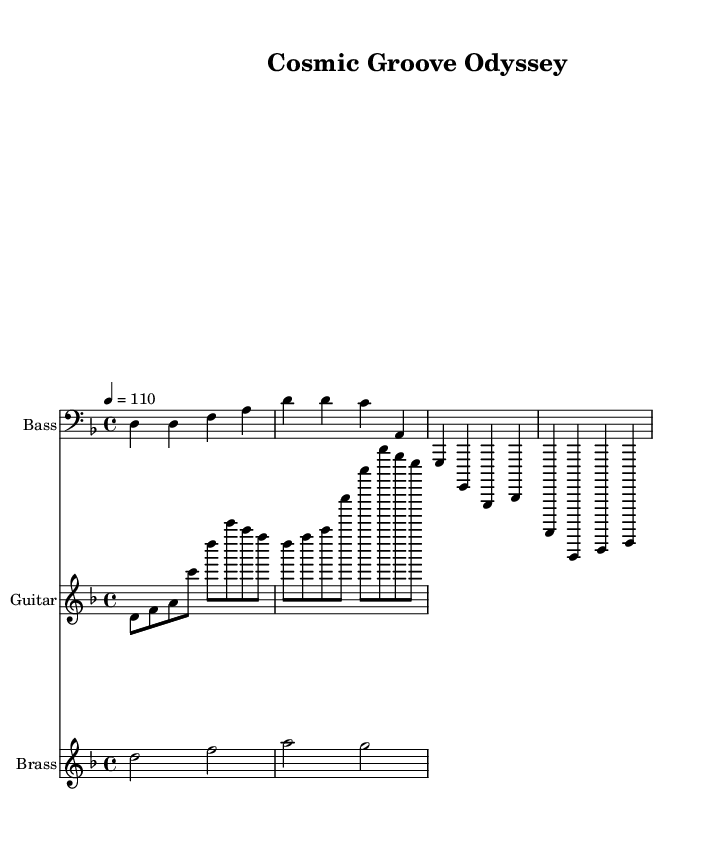What is the key signature of this music? The key signature of the music is indicated at the beginning of the score. It includes one flat (B♭), which signifies the key of D minor.
Answer: D minor What is the time signature of the piece? The time signature is displayed at the beginning of the score and is represented as 4/4, indicating four beats per measure and the quarter note gets one beat.
Answer: 4/4 What is the tempo marking for the music? The tempo marking is specified at the beginning as "4 = 110," which indicates that a quarter note should be played at a speed of 110 beats per minute.
Answer: 110 How many sections are there in the score? The score consists of three separate staves, indicating three distinct musical sections: Bass, Guitar, and Brass.
Answer: 3 What note length predominates the bass line? The bass line is primarily composed of quarter notes, which are represented as note values that fill one beat in a 4/4 measure.
Answer: Quarter notes Which instruments are featured in the composition? The score clearly labels three staves with corresponding instrument names: Bass, Guitar, and Brass, indicating these are the featured instruments in the composition.
Answer: Bass, Guitar, Brass What musical genre does this piece exemplify? The musical elements present in the score, such as syncopated rhythms and use of grooves, along with the title "Cosmic Groove Odyssey," indicate that this piece is in the genre of Funk.
Answer: Funk 